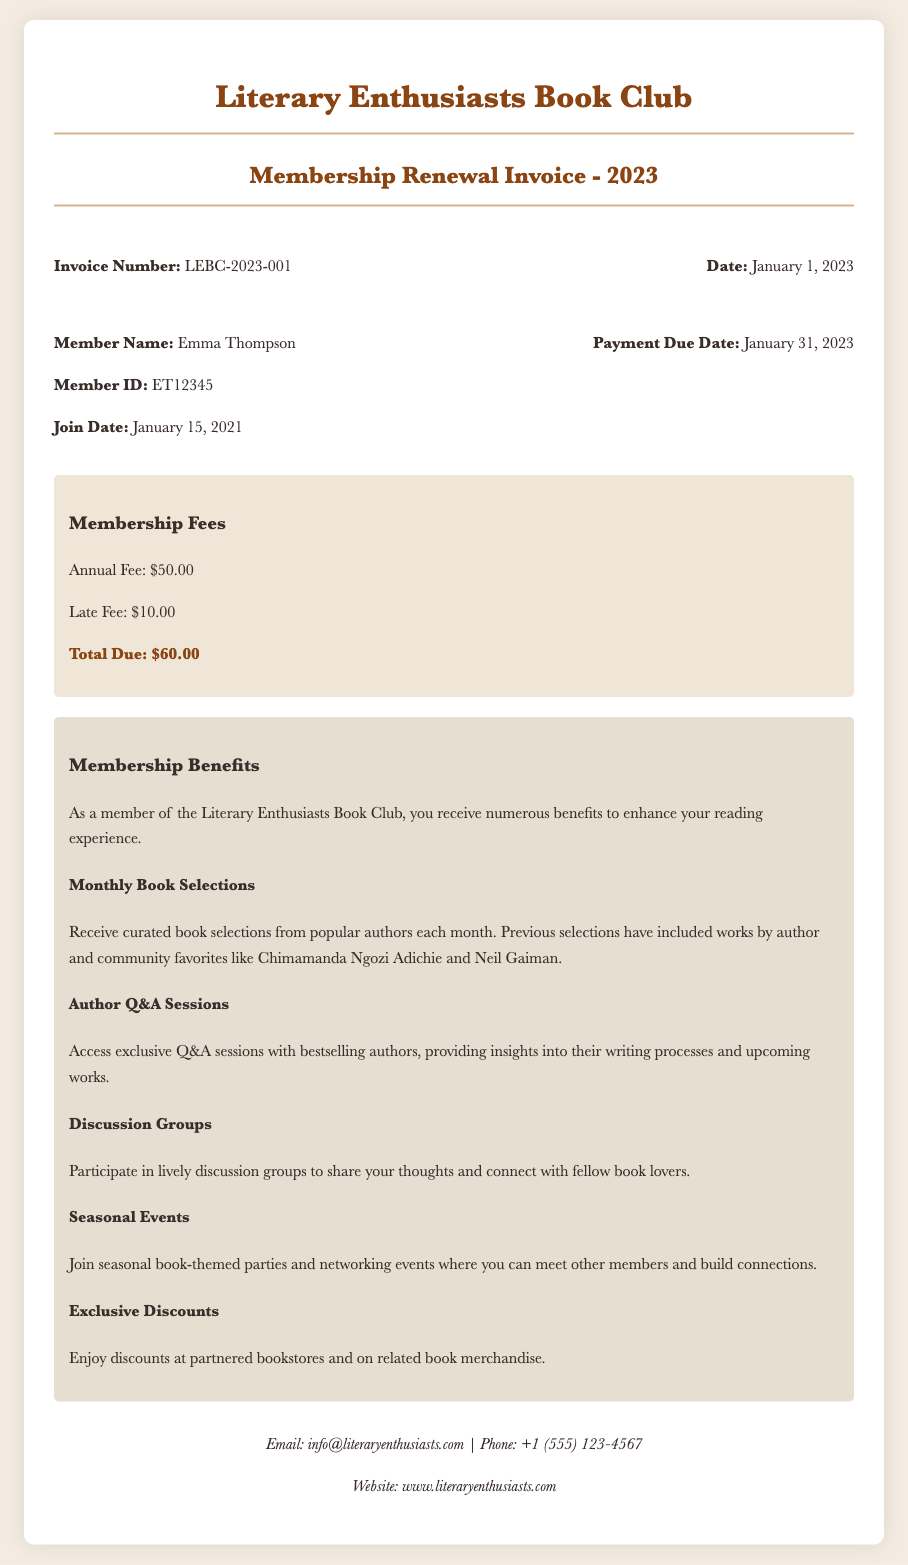What is the invoice number? The invoice number is listed prominently in the document, specifically as "LEBC-2023-001".
Answer: LEBC-2023-001 What is the total due amount? The total due is specified in the fees section of the document as $60.00.
Answer: $60.00 Who is the member? The document mentions the member's name as "Emma Thompson".
Answer: Emma Thompson What is the annual fee for membership? The document indicates that the annual fee is $50.00.
Answer: $50.00 What is the payment due date? The payment due date is stated in the member details, which is January 31, 2023.
Answer: January 31, 2023 What type of events do members join seasonally? The document mentions "book-themed parties and networking events" as seasonal events for members.
Answer: book-themed parties and networking events Which magazine subscriptions are included in the membership benefits? Membership benefits include "Monthly Book Selections" from popular authors.
Answer: Monthly Book Selections How long has Emma Thompson been a member? The join date on the document indicates she has been a member since January 15, 2021, which is 2 years and about 1 month.
Answer: 2 years and about 1 month What is one way members connect with authors? The document specifies "exclusive Q&A sessions with bestselling authors" as a way for members to connect.
Answer: exclusive Q&A sessions 